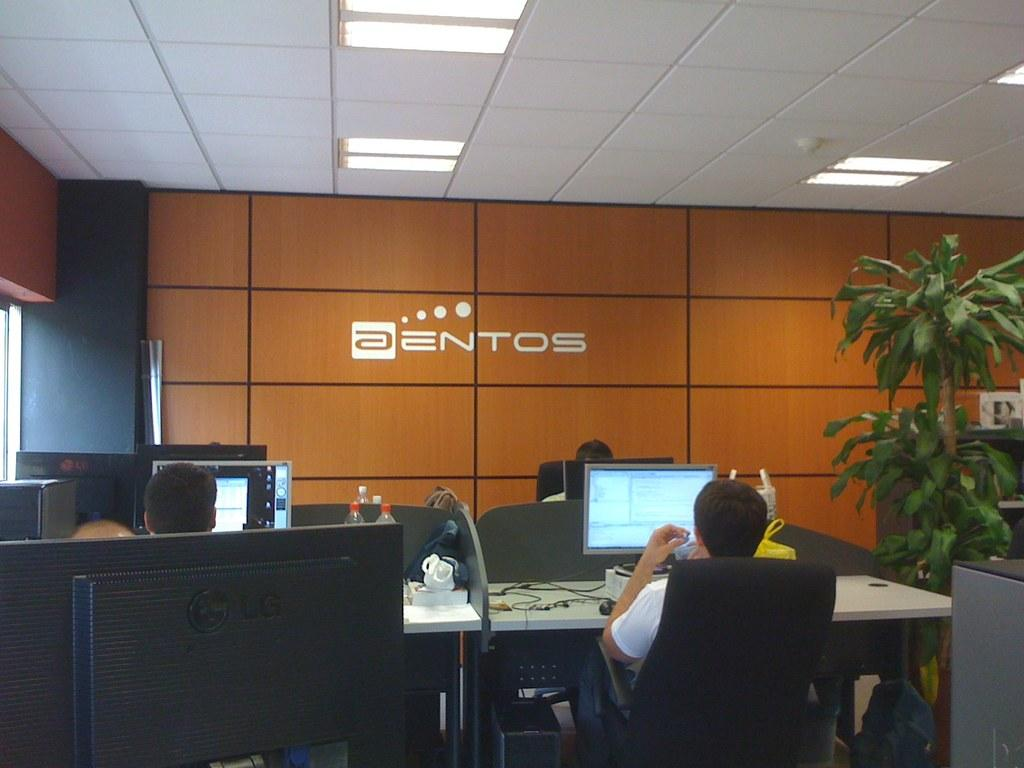Provide a one-sentence caption for the provided image. Employees work in their cubicles at the Aentos company. 